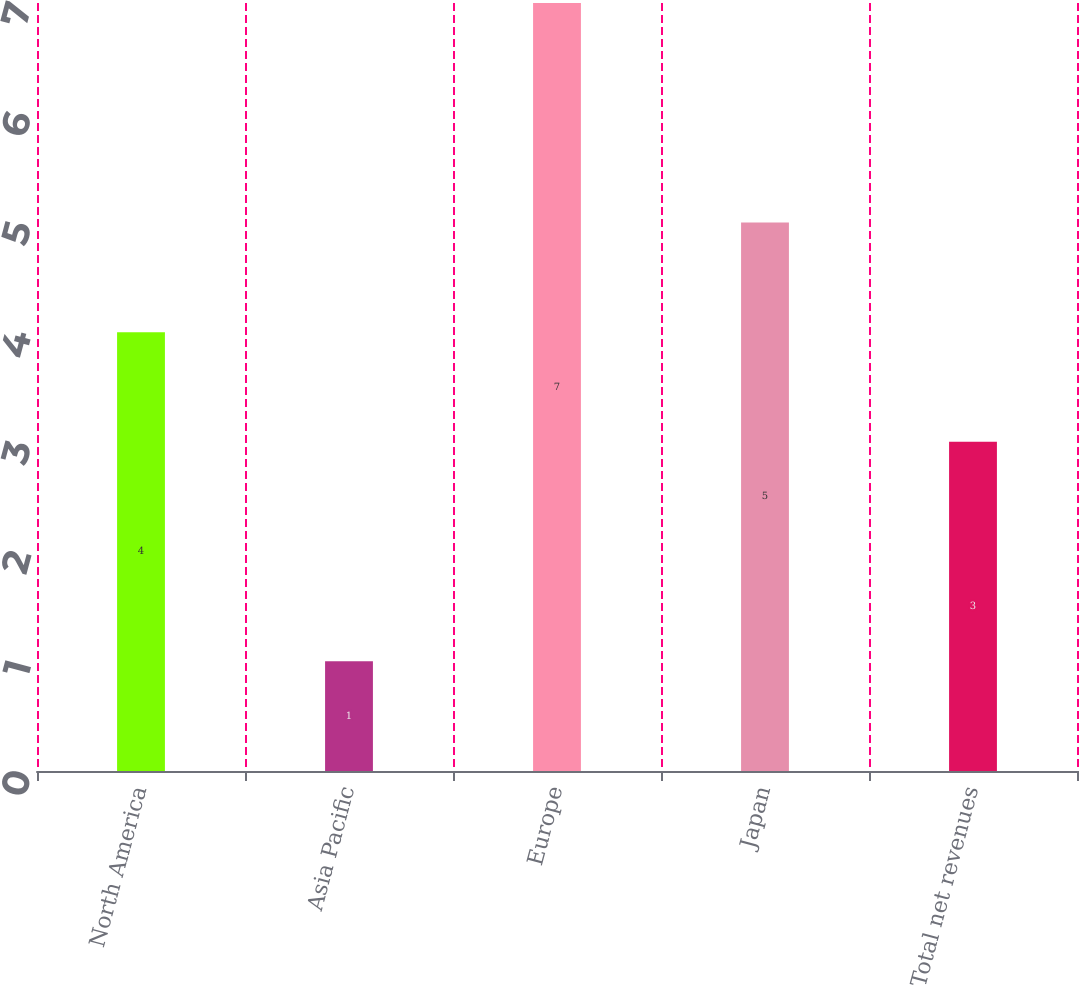<chart> <loc_0><loc_0><loc_500><loc_500><bar_chart><fcel>North America<fcel>Asia Pacific<fcel>Europe<fcel>Japan<fcel>Total net revenues<nl><fcel>4<fcel>1<fcel>7<fcel>5<fcel>3<nl></chart> 